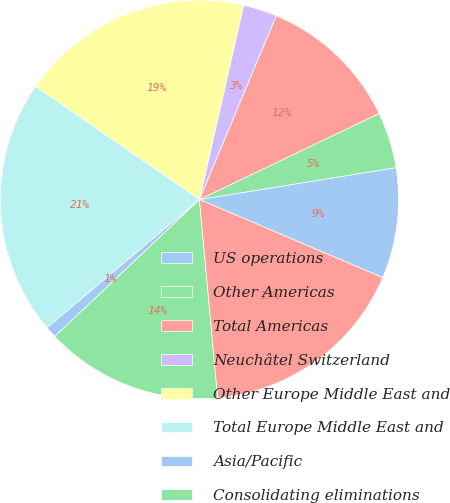Convert chart to OTSL. <chart><loc_0><loc_0><loc_500><loc_500><pie_chart><fcel>US operations<fcel>Other Americas<fcel>Total Americas<fcel>Neuchâtel Switzerland<fcel>Other Europe Middle East and<fcel>Total Europe Middle East and<fcel>Asia/Pacific<fcel>Consolidating eliminations<fcel>Total long-lived assets<nl><fcel>8.97%<fcel>4.55%<fcel>11.59%<fcel>2.74%<fcel>18.94%<fcel>20.75%<fcel>0.93%<fcel>14.4%<fcel>17.13%<nl></chart> 